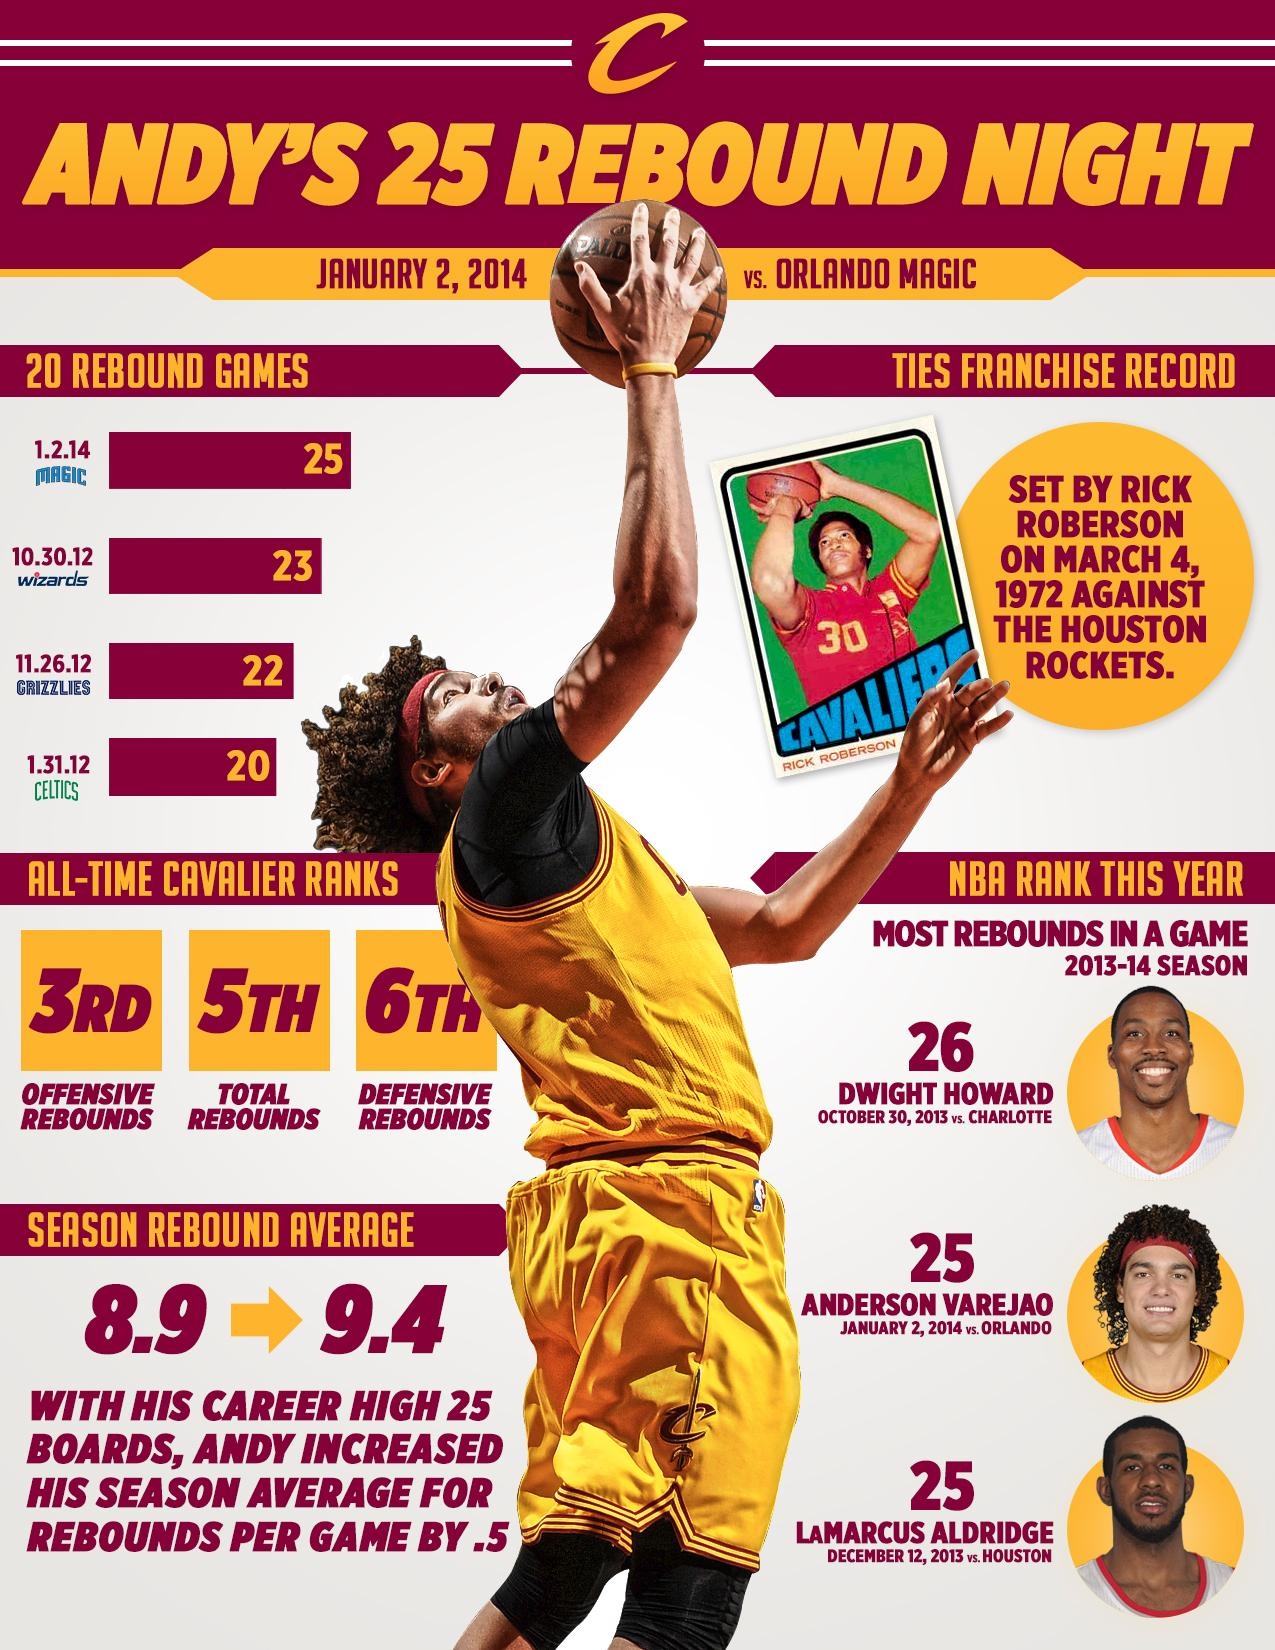Highlight a few significant elements in this photo. The number written on the jersey of Rick Roberson is 30. In a span of 20 games, the player achieved an impressive feat by recording double-digit rebounds against the Wizards, Grizzlies, and Celtics. With certainty, I declare that the jersey color of Rick Roberson is red. You are stating that based on historical data, you are currently ranked 6th in all-time Cavalier records for defensive rebounds. Anderson Varejao and LaMarcus Aldridge are ranked 25th in the most rebounds in a game during the 2013-2014 season. 